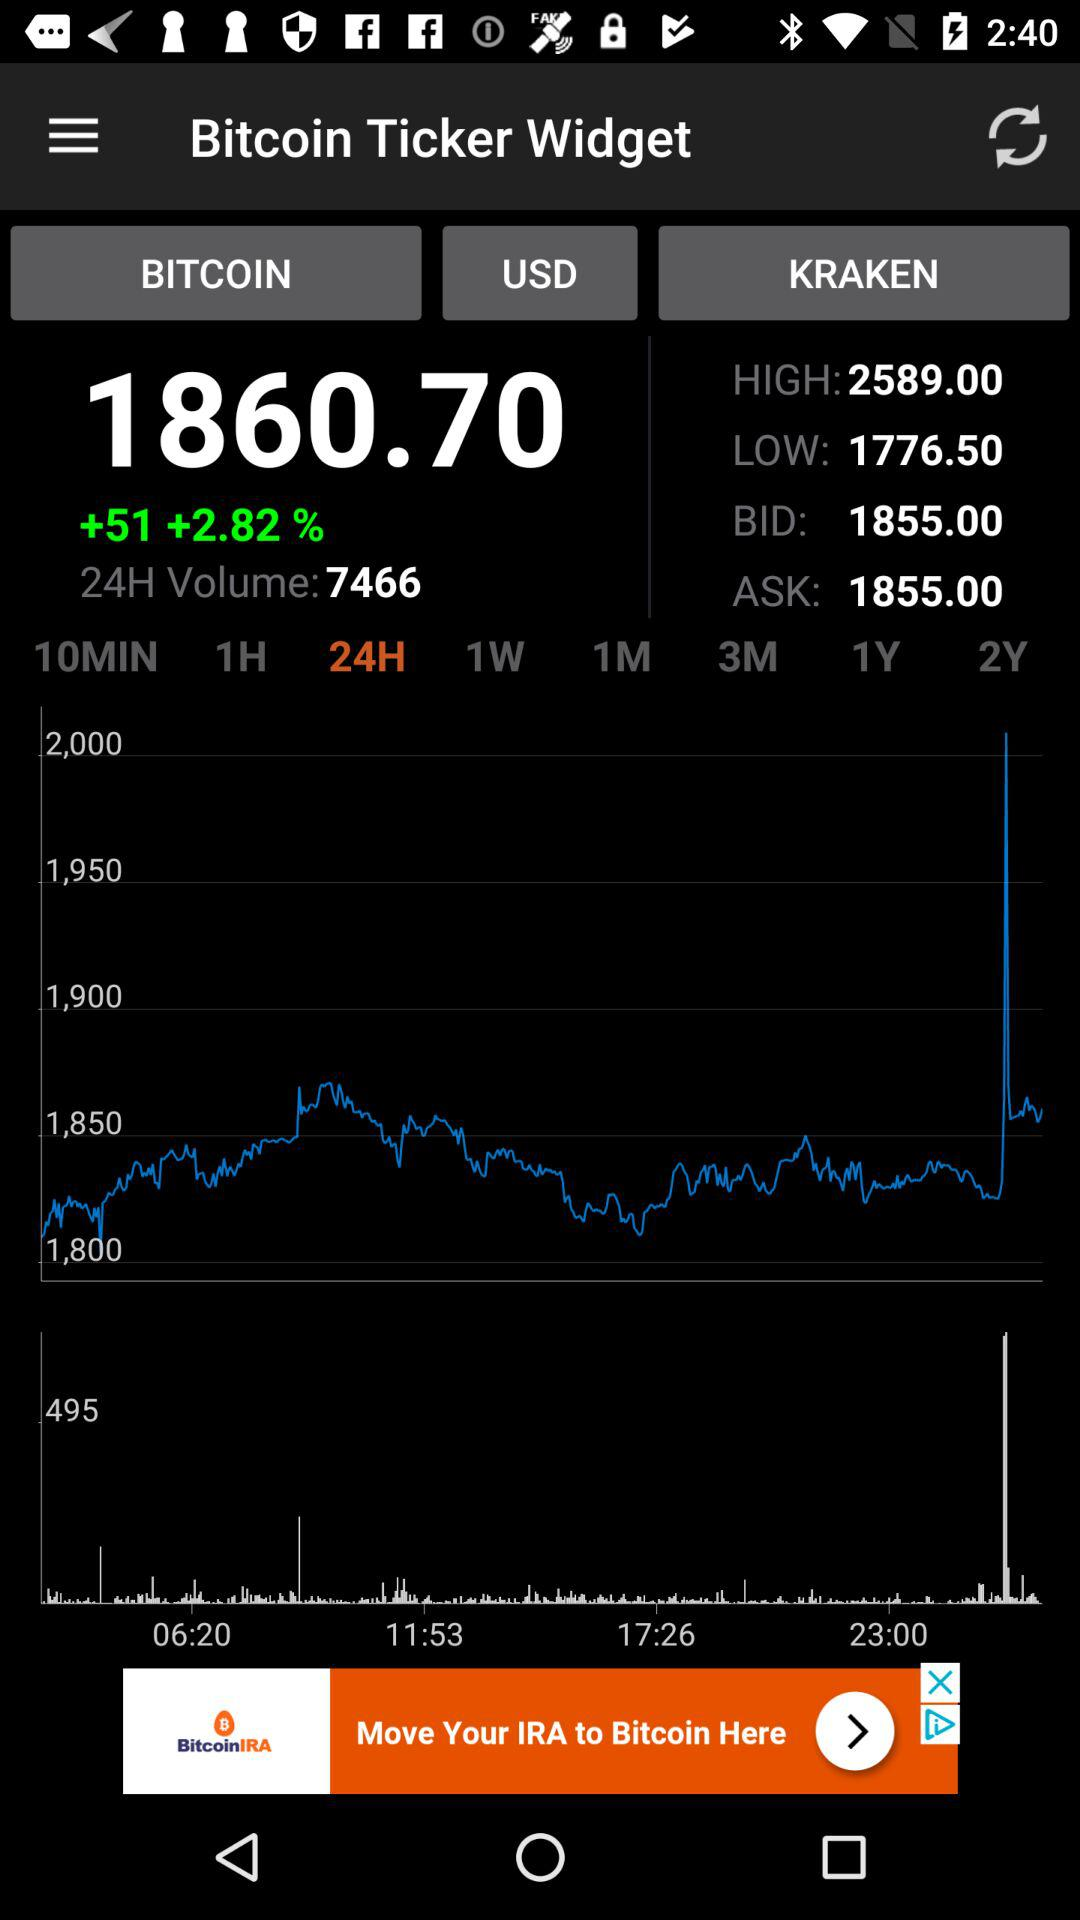What is the lowest kraken? The lowest kraken is 1776.50. 